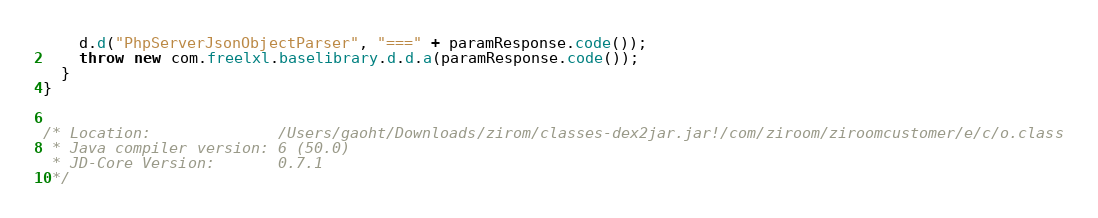Convert code to text. <code><loc_0><loc_0><loc_500><loc_500><_Java_>    d.d("PhpServerJsonObjectParser", "===" + paramResponse.code());
    throw new com.freelxl.baselibrary.d.d.a(paramResponse.code());
  }
}


/* Location:              /Users/gaoht/Downloads/zirom/classes-dex2jar.jar!/com/ziroom/ziroomcustomer/e/c/o.class
 * Java compiler version: 6 (50.0)
 * JD-Core Version:       0.7.1
 */</code> 